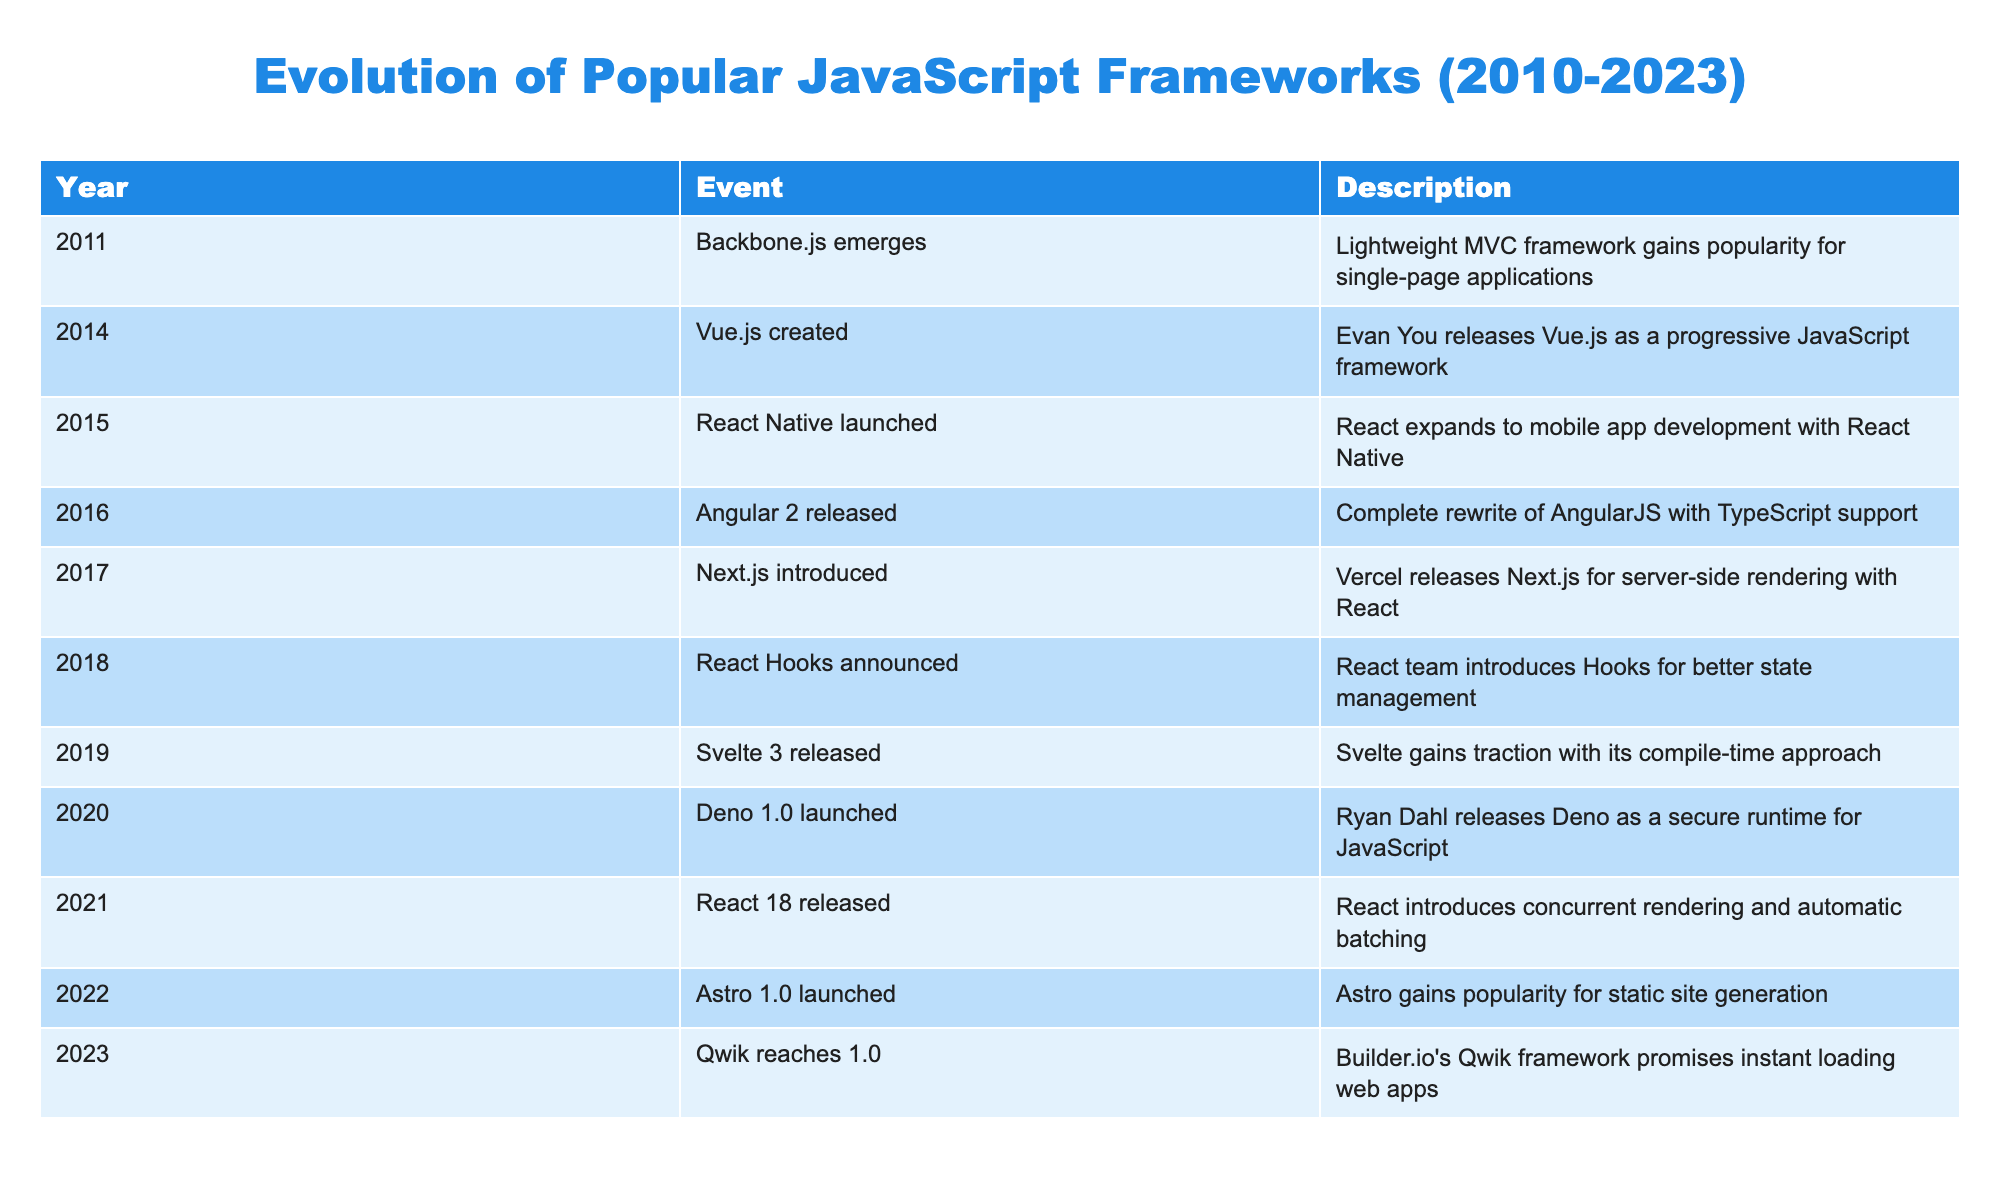What year was Vue.js created? Vue.js was created in 2014 according to the second row of the table that lists events.
Answer: 2014 Which framework was released first, React Native or Angular 2? React Native was launched in 2015, while Angular 2 was released in 2016. Since 2015 comes before 2016, React Native was released first.
Answer: React Native How many JavaScript frameworks were introduced between 2010 and 2015? From the table, the frameworks introduced between 2010 and 2015 are Backbone.js (2011), Vue.js (2014), and React Native (2015). Counting these gives us a total of 3 frameworks.
Answer: 3 Is it true that Astro was released before Svelte 3? The table shows that Svelte 3 was released in 2019 and Astro in 2022. Since 2019 comes before 2022, this statement is false.
Answer: No What is the difference in years between the release of Next.js and Qwik? Next.js was introduced in 2017 and Qwik was released in 2023. The difference is 2023 - 2017 = 6 years.
Answer: 6 years How many frameworks were released after 2020? The frameworks released after 2020 are React 18 (2021), Astro 1.0 (2022), and Qwik (2023). Counting these gives us 3 frameworks released after 2020.
Answer: 3 What is the chronological order of frameworks from React Native to Qwik? Referring to the table, the frameworks in chronological order are React Native (2015), Angular 2 (2016), Next.js (2017), React Hooks (2018), Svelte 3 (2019), Deno (2020), React 18 (2021), Astro (2022), and Qwik (2023). Thus, the order is as listed.
Answer: React Native, Angular 2, Next.js, React Hooks, Svelte 3, Deno, React 18, Astro, Qwik Was there any framework that gained popularity for static site generation before Astro? The table shows that Astro was launched in 2022, and there are no earlier frameworks mentioned focusing on static site generation, so the answer is no.
Answer: No 